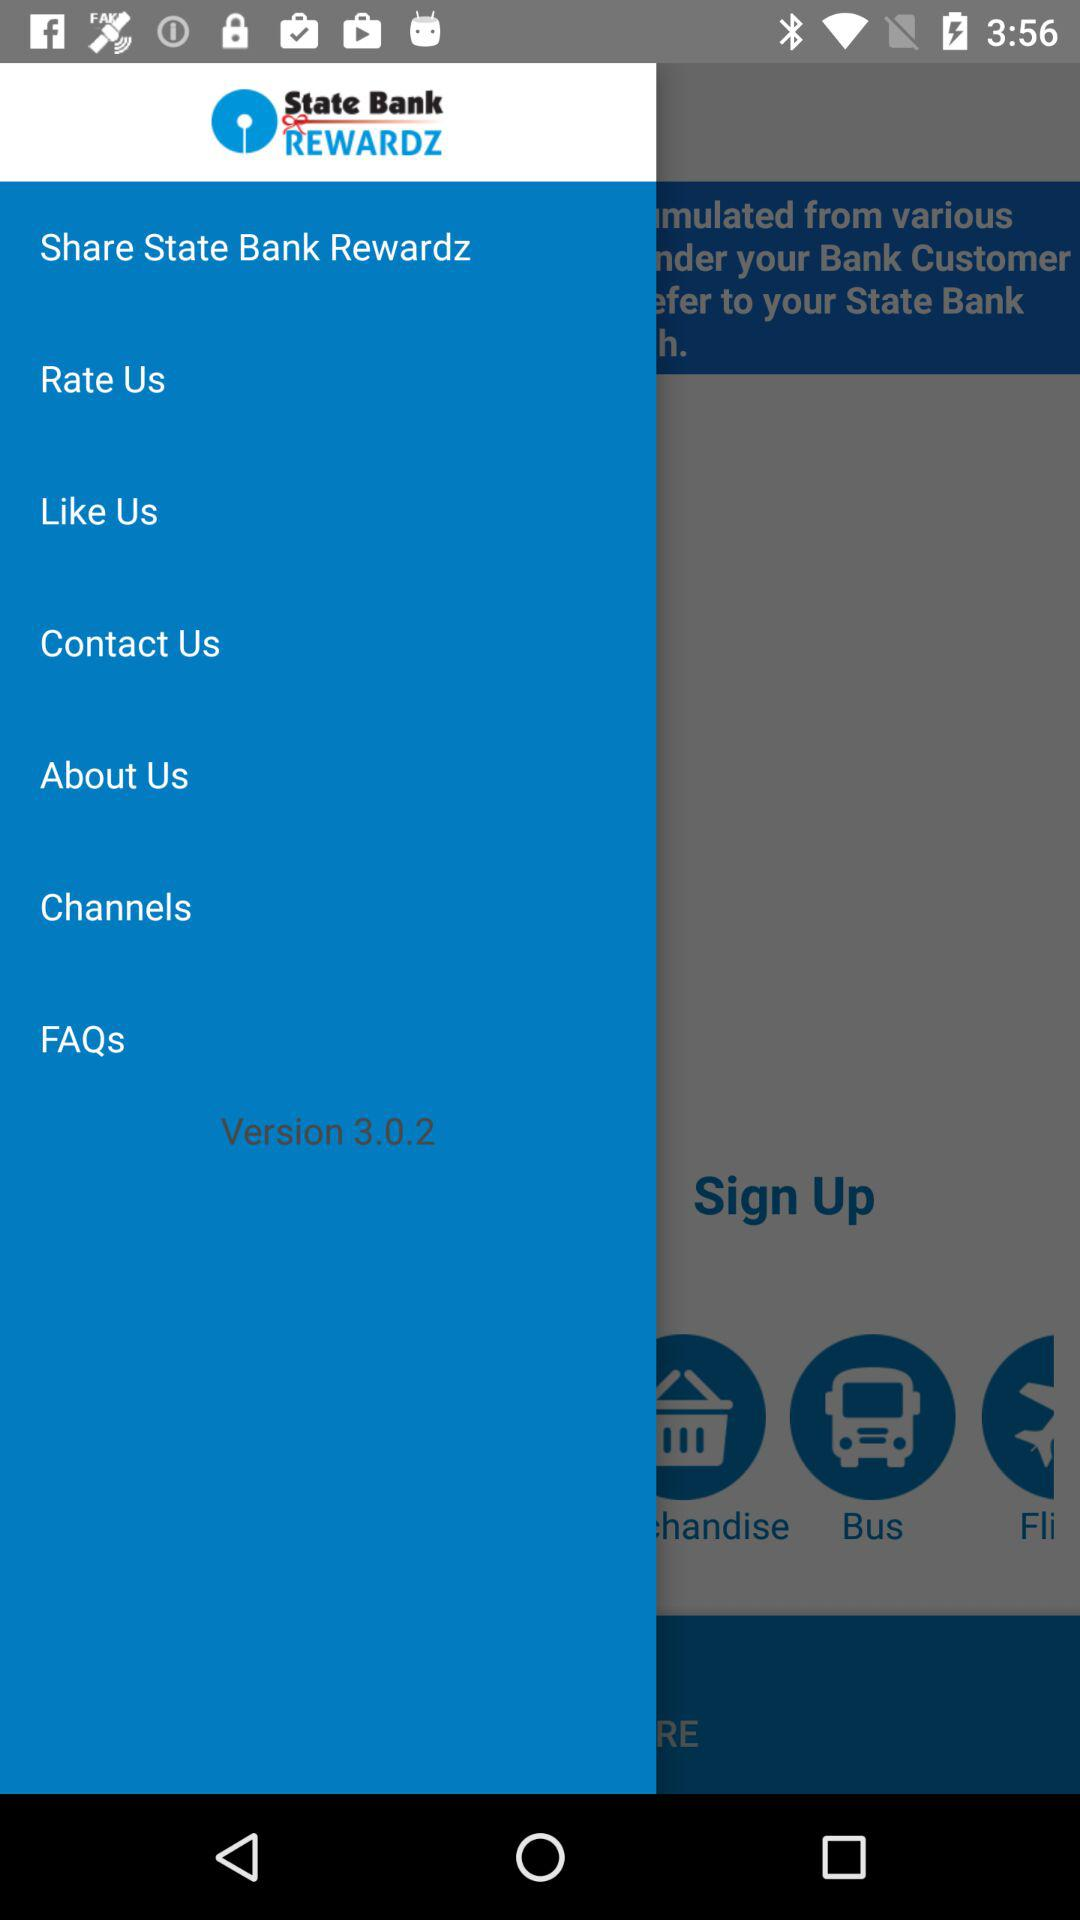Which version is used? The used version is 3.0.2. 